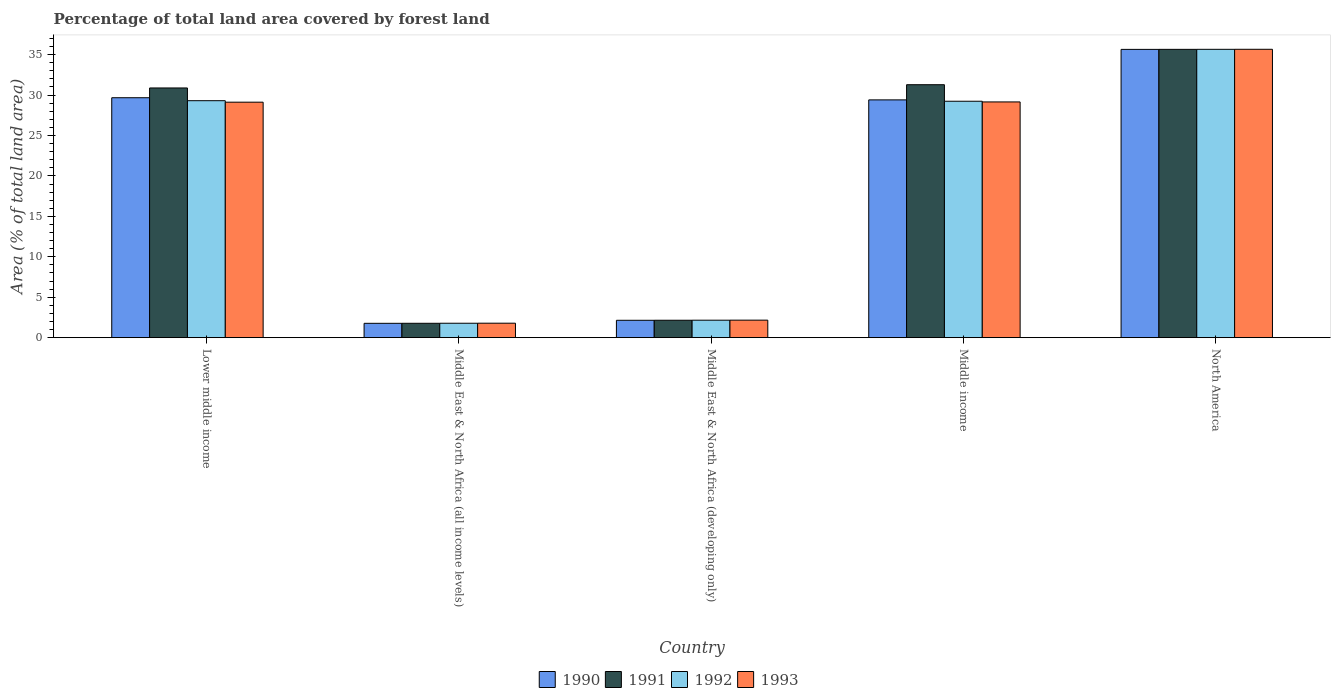How many groups of bars are there?
Your response must be concise. 5. Are the number of bars per tick equal to the number of legend labels?
Provide a succinct answer. Yes. How many bars are there on the 4th tick from the right?
Your response must be concise. 4. What is the label of the 1st group of bars from the left?
Provide a succinct answer. Lower middle income. What is the percentage of forest land in 1991 in North America?
Make the answer very short. 35.65. Across all countries, what is the maximum percentage of forest land in 1993?
Provide a short and direct response. 35.66. Across all countries, what is the minimum percentage of forest land in 1992?
Ensure brevity in your answer.  1.78. In which country was the percentage of forest land in 1992 minimum?
Your response must be concise. Middle East & North Africa (all income levels). What is the total percentage of forest land in 1992 in the graph?
Offer a terse response. 98.14. What is the difference between the percentage of forest land in 1992 in Middle East & North Africa (all income levels) and that in Middle East & North Africa (developing only)?
Your answer should be very brief. -0.38. What is the difference between the percentage of forest land in 1992 in Middle East & North Africa (all income levels) and the percentage of forest land in 1993 in North America?
Provide a short and direct response. -33.88. What is the average percentage of forest land in 1992 per country?
Ensure brevity in your answer.  19.63. What is the difference between the percentage of forest land of/in 1991 and percentage of forest land of/in 1990 in Middle income?
Keep it short and to the point. 1.88. What is the ratio of the percentage of forest land in 1991 in Middle East & North Africa (all income levels) to that in North America?
Provide a succinct answer. 0.05. What is the difference between the highest and the second highest percentage of forest land in 1993?
Offer a very short reply. -6.54. What is the difference between the highest and the lowest percentage of forest land in 1993?
Keep it short and to the point. 33.87. In how many countries, is the percentage of forest land in 1993 greater than the average percentage of forest land in 1993 taken over all countries?
Keep it short and to the point. 3. Is it the case that in every country, the sum of the percentage of forest land in 1991 and percentage of forest land in 1990 is greater than the sum of percentage of forest land in 1992 and percentage of forest land in 1993?
Your response must be concise. No. What does the 3rd bar from the left in Middle East & North Africa (all income levels) represents?
Provide a succinct answer. 1992. What does the 3rd bar from the right in Middle income represents?
Your answer should be compact. 1991. How many bars are there?
Offer a terse response. 20. How many countries are there in the graph?
Give a very brief answer. 5. What is the difference between two consecutive major ticks on the Y-axis?
Offer a terse response. 5. Does the graph contain any zero values?
Offer a very short reply. No. What is the title of the graph?
Your answer should be compact. Percentage of total land area covered by forest land. Does "1992" appear as one of the legend labels in the graph?
Keep it short and to the point. Yes. What is the label or title of the X-axis?
Your answer should be very brief. Country. What is the label or title of the Y-axis?
Keep it short and to the point. Area (% of total land area). What is the Area (% of total land area) of 1990 in Lower middle income?
Your answer should be compact. 29.67. What is the Area (% of total land area) of 1991 in Lower middle income?
Your response must be concise. 30.88. What is the Area (% of total land area) of 1992 in Lower middle income?
Your answer should be compact. 29.31. What is the Area (% of total land area) of 1993 in Lower middle income?
Offer a terse response. 29.12. What is the Area (% of total land area) in 1990 in Middle East & North Africa (all income levels)?
Provide a succinct answer. 1.77. What is the Area (% of total land area) in 1991 in Middle East & North Africa (all income levels)?
Your answer should be very brief. 1.78. What is the Area (% of total land area) in 1992 in Middle East & North Africa (all income levels)?
Provide a succinct answer. 1.78. What is the Area (% of total land area) of 1993 in Middle East & North Africa (all income levels)?
Provide a short and direct response. 1.79. What is the Area (% of total land area) in 1990 in Middle East & North Africa (developing only)?
Ensure brevity in your answer.  2.15. What is the Area (% of total land area) of 1991 in Middle East & North Africa (developing only)?
Offer a very short reply. 2.15. What is the Area (% of total land area) in 1992 in Middle East & North Africa (developing only)?
Your answer should be compact. 2.16. What is the Area (% of total land area) of 1993 in Middle East & North Africa (developing only)?
Provide a succinct answer. 2.17. What is the Area (% of total land area) in 1990 in Middle income?
Ensure brevity in your answer.  29.41. What is the Area (% of total land area) in 1991 in Middle income?
Keep it short and to the point. 31.28. What is the Area (% of total land area) in 1992 in Middle income?
Give a very brief answer. 29.24. What is the Area (% of total land area) in 1993 in Middle income?
Provide a succinct answer. 29.15. What is the Area (% of total land area) of 1990 in North America?
Your answer should be very brief. 35.65. What is the Area (% of total land area) in 1991 in North America?
Your answer should be very brief. 35.65. What is the Area (% of total land area) in 1992 in North America?
Give a very brief answer. 35.66. What is the Area (% of total land area) in 1993 in North America?
Give a very brief answer. 35.66. Across all countries, what is the maximum Area (% of total land area) of 1990?
Your response must be concise. 35.65. Across all countries, what is the maximum Area (% of total land area) in 1991?
Provide a short and direct response. 35.65. Across all countries, what is the maximum Area (% of total land area) in 1992?
Your response must be concise. 35.66. Across all countries, what is the maximum Area (% of total land area) in 1993?
Offer a very short reply. 35.66. Across all countries, what is the minimum Area (% of total land area) in 1990?
Your answer should be very brief. 1.77. Across all countries, what is the minimum Area (% of total land area) of 1991?
Ensure brevity in your answer.  1.78. Across all countries, what is the minimum Area (% of total land area) in 1992?
Provide a short and direct response. 1.78. Across all countries, what is the minimum Area (% of total land area) of 1993?
Your answer should be compact. 1.79. What is the total Area (% of total land area) of 1990 in the graph?
Offer a terse response. 98.65. What is the total Area (% of total land area) in 1991 in the graph?
Your answer should be compact. 101.75. What is the total Area (% of total land area) of 1992 in the graph?
Your answer should be very brief. 98.14. What is the total Area (% of total land area) of 1993 in the graph?
Keep it short and to the point. 97.89. What is the difference between the Area (% of total land area) of 1990 in Lower middle income and that in Middle East & North Africa (all income levels)?
Offer a terse response. 27.9. What is the difference between the Area (% of total land area) of 1991 in Lower middle income and that in Middle East & North Africa (all income levels)?
Provide a succinct answer. 29.1. What is the difference between the Area (% of total land area) of 1992 in Lower middle income and that in Middle East & North Africa (all income levels)?
Provide a short and direct response. 27.52. What is the difference between the Area (% of total land area) of 1993 in Lower middle income and that in Middle East & North Africa (all income levels)?
Make the answer very short. 27.33. What is the difference between the Area (% of total land area) of 1990 in Lower middle income and that in Middle East & North Africa (developing only)?
Provide a short and direct response. 27.52. What is the difference between the Area (% of total land area) of 1991 in Lower middle income and that in Middle East & North Africa (developing only)?
Your answer should be very brief. 28.73. What is the difference between the Area (% of total land area) of 1992 in Lower middle income and that in Middle East & North Africa (developing only)?
Your response must be concise. 27.15. What is the difference between the Area (% of total land area) in 1993 in Lower middle income and that in Middle East & North Africa (developing only)?
Your answer should be compact. 26.96. What is the difference between the Area (% of total land area) in 1990 in Lower middle income and that in Middle income?
Ensure brevity in your answer.  0.27. What is the difference between the Area (% of total land area) in 1991 in Lower middle income and that in Middle income?
Provide a short and direct response. -0.4. What is the difference between the Area (% of total land area) in 1992 in Lower middle income and that in Middle income?
Your response must be concise. 0.07. What is the difference between the Area (% of total land area) in 1993 in Lower middle income and that in Middle income?
Keep it short and to the point. -0.03. What is the difference between the Area (% of total land area) of 1990 in Lower middle income and that in North America?
Give a very brief answer. -5.98. What is the difference between the Area (% of total land area) of 1991 in Lower middle income and that in North America?
Offer a terse response. -4.78. What is the difference between the Area (% of total land area) in 1992 in Lower middle income and that in North America?
Offer a terse response. -6.35. What is the difference between the Area (% of total land area) of 1993 in Lower middle income and that in North America?
Provide a succinct answer. -6.54. What is the difference between the Area (% of total land area) of 1990 in Middle East & North Africa (all income levels) and that in Middle East & North Africa (developing only)?
Offer a very short reply. -0.38. What is the difference between the Area (% of total land area) of 1991 in Middle East & North Africa (all income levels) and that in Middle East & North Africa (developing only)?
Give a very brief answer. -0.38. What is the difference between the Area (% of total land area) of 1992 in Middle East & North Africa (all income levels) and that in Middle East & North Africa (developing only)?
Your answer should be very brief. -0.38. What is the difference between the Area (% of total land area) in 1993 in Middle East & North Africa (all income levels) and that in Middle East & North Africa (developing only)?
Keep it short and to the point. -0.38. What is the difference between the Area (% of total land area) of 1990 in Middle East & North Africa (all income levels) and that in Middle income?
Your answer should be very brief. -27.63. What is the difference between the Area (% of total land area) in 1991 in Middle East & North Africa (all income levels) and that in Middle income?
Ensure brevity in your answer.  -29.5. What is the difference between the Area (% of total land area) in 1992 in Middle East & North Africa (all income levels) and that in Middle income?
Ensure brevity in your answer.  -27.45. What is the difference between the Area (% of total land area) of 1993 in Middle East & North Africa (all income levels) and that in Middle income?
Your answer should be very brief. -27.36. What is the difference between the Area (% of total land area) of 1990 in Middle East & North Africa (all income levels) and that in North America?
Your answer should be very brief. -33.88. What is the difference between the Area (% of total land area) in 1991 in Middle East & North Africa (all income levels) and that in North America?
Provide a short and direct response. -33.88. What is the difference between the Area (% of total land area) of 1992 in Middle East & North Africa (all income levels) and that in North America?
Keep it short and to the point. -33.87. What is the difference between the Area (% of total land area) in 1993 in Middle East & North Africa (all income levels) and that in North America?
Your answer should be compact. -33.87. What is the difference between the Area (% of total land area) in 1990 in Middle East & North Africa (developing only) and that in Middle income?
Ensure brevity in your answer.  -27.26. What is the difference between the Area (% of total land area) of 1991 in Middle East & North Africa (developing only) and that in Middle income?
Offer a terse response. -29.13. What is the difference between the Area (% of total land area) in 1992 in Middle East & North Africa (developing only) and that in Middle income?
Your answer should be very brief. -27.08. What is the difference between the Area (% of total land area) in 1993 in Middle East & North Africa (developing only) and that in Middle income?
Offer a very short reply. -26.99. What is the difference between the Area (% of total land area) of 1990 in Middle East & North Africa (developing only) and that in North America?
Provide a succinct answer. -33.5. What is the difference between the Area (% of total land area) of 1991 in Middle East & North Africa (developing only) and that in North America?
Your response must be concise. -33.5. What is the difference between the Area (% of total land area) of 1992 in Middle East & North Africa (developing only) and that in North America?
Provide a succinct answer. -33.5. What is the difference between the Area (% of total land area) of 1993 in Middle East & North Africa (developing only) and that in North America?
Keep it short and to the point. -33.5. What is the difference between the Area (% of total land area) in 1990 in Middle income and that in North America?
Your answer should be compact. -6.25. What is the difference between the Area (% of total land area) in 1991 in Middle income and that in North America?
Provide a succinct answer. -4.37. What is the difference between the Area (% of total land area) of 1992 in Middle income and that in North America?
Provide a short and direct response. -6.42. What is the difference between the Area (% of total land area) of 1993 in Middle income and that in North America?
Your response must be concise. -6.51. What is the difference between the Area (% of total land area) of 1990 in Lower middle income and the Area (% of total land area) of 1991 in Middle East & North Africa (all income levels)?
Provide a short and direct response. 27.89. What is the difference between the Area (% of total land area) in 1990 in Lower middle income and the Area (% of total land area) in 1992 in Middle East & North Africa (all income levels)?
Your response must be concise. 27.89. What is the difference between the Area (% of total land area) in 1990 in Lower middle income and the Area (% of total land area) in 1993 in Middle East & North Africa (all income levels)?
Keep it short and to the point. 27.88. What is the difference between the Area (% of total land area) in 1991 in Lower middle income and the Area (% of total land area) in 1992 in Middle East & North Africa (all income levels)?
Provide a succinct answer. 29.1. What is the difference between the Area (% of total land area) in 1991 in Lower middle income and the Area (% of total land area) in 1993 in Middle East & North Africa (all income levels)?
Ensure brevity in your answer.  29.09. What is the difference between the Area (% of total land area) of 1992 in Lower middle income and the Area (% of total land area) of 1993 in Middle East & North Africa (all income levels)?
Provide a succinct answer. 27.52. What is the difference between the Area (% of total land area) in 1990 in Lower middle income and the Area (% of total land area) in 1991 in Middle East & North Africa (developing only)?
Keep it short and to the point. 27.52. What is the difference between the Area (% of total land area) in 1990 in Lower middle income and the Area (% of total land area) in 1992 in Middle East & North Africa (developing only)?
Give a very brief answer. 27.51. What is the difference between the Area (% of total land area) in 1990 in Lower middle income and the Area (% of total land area) in 1993 in Middle East & North Africa (developing only)?
Ensure brevity in your answer.  27.51. What is the difference between the Area (% of total land area) in 1991 in Lower middle income and the Area (% of total land area) in 1992 in Middle East & North Africa (developing only)?
Provide a short and direct response. 28.72. What is the difference between the Area (% of total land area) of 1991 in Lower middle income and the Area (% of total land area) of 1993 in Middle East & North Africa (developing only)?
Provide a succinct answer. 28.71. What is the difference between the Area (% of total land area) of 1992 in Lower middle income and the Area (% of total land area) of 1993 in Middle East & North Africa (developing only)?
Offer a terse response. 27.14. What is the difference between the Area (% of total land area) of 1990 in Lower middle income and the Area (% of total land area) of 1991 in Middle income?
Your answer should be very brief. -1.61. What is the difference between the Area (% of total land area) of 1990 in Lower middle income and the Area (% of total land area) of 1992 in Middle income?
Offer a terse response. 0.43. What is the difference between the Area (% of total land area) in 1990 in Lower middle income and the Area (% of total land area) in 1993 in Middle income?
Offer a terse response. 0.52. What is the difference between the Area (% of total land area) of 1991 in Lower middle income and the Area (% of total land area) of 1992 in Middle income?
Your answer should be compact. 1.64. What is the difference between the Area (% of total land area) in 1991 in Lower middle income and the Area (% of total land area) in 1993 in Middle income?
Your answer should be very brief. 1.73. What is the difference between the Area (% of total land area) in 1992 in Lower middle income and the Area (% of total land area) in 1993 in Middle income?
Give a very brief answer. 0.15. What is the difference between the Area (% of total land area) in 1990 in Lower middle income and the Area (% of total land area) in 1991 in North America?
Provide a short and direct response. -5.98. What is the difference between the Area (% of total land area) of 1990 in Lower middle income and the Area (% of total land area) of 1992 in North America?
Make the answer very short. -5.99. What is the difference between the Area (% of total land area) in 1990 in Lower middle income and the Area (% of total land area) in 1993 in North America?
Your answer should be very brief. -5.99. What is the difference between the Area (% of total land area) of 1991 in Lower middle income and the Area (% of total land area) of 1992 in North America?
Offer a very short reply. -4.78. What is the difference between the Area (% of total land area) in 1991 in Lower middle income and the Area (% of total land area) in 1993 in North America?
Keep it short and to the point. -4.78. What is the difference between the Area (% of total land area) in 1992 in Lower middle income and the Area (% of total land area) in 1993 in North America?
Offer a very short reply. -6.36. What is the difference between the Area (% of total land area) of 1990 in Middle East & North Africa (all income levels) and the Area (% of total land area) of 1991 in Middle East & North Africa (developing only)?
Keep it short and to the point. -0.38. What is the difference between the Area (% of total land area) of 1990 in Middle East & North Africa (all income levels) and the Area (% of total land area) of 1992 in Middle East & North Africa (developing only)?
Ensure brevity in your answer.  -0.39. What is the difference between the Area (% of total land area) in 1990 in Middle East & North Africa (all income levels) and the Area (% of total land area) in 1993 in Middle East & North Africa (developing only)?
Your response must be concise. -0.39. What is the difference between the Area (% of total land area) of 1991 in Middle East & North Africa (all income levels) and the Area (% of total land area) of 1992 in Middle East & North Africa (developing only)?
Your response must be concise. -0.38. What is the difference between the Area (% of total land area) in 1991 in Middle East & North Africa (all income levels) and the Area (% of total land area) in 1993 in Middle East & North Africa (developing only)?
Offer a very short reply. -0.39. What is the difference between the Area (% of total land area) in 1992 in Middle East & North Africa (all income levels) and the Area (% of total land area) in 1993 in Middle East & North Africa (developing only)?
Offer a terse response. -0.38. What is the difference between the Area (% of total land area) of 1990 in Middle East & North Africa (all income levels) and the Area (% of total land area) of 1991 in Middle income?
Offer a terse response. -29.51. What is the difference between the Area (% of total land area) in 1990 in Middle East & North Africa (all income levels) and the Area (% of total land area) in 1992 in Middle income?
Offer a terse response. -27.46. What is the difference between the Area (% of total land area) of 1990 in Middle East & North Africa (all income levels) and the Area (% of total land area) of 1993 in Middle income?
Make the answer very short. -27.38. What is the difference between the Area (% of total land area) of 1991 in Middle East & North Africa (all income levels) and the Area (% of total land area) of 1992 in Middle income?
Make the answer very short. -27.46. What is the difference between the Area (% of total land area) in 1991 in Middle East & North Africa (all income levels) and the Area (% of total land area) in 1993 in Middle income?
Make the answer very short. -27.37. What is the difference between the Area (% of total land area) in 1992 in Middle East & North Africa (all income levels) and the Area (% of total land area) in 1993 in Middle income?
Provide a short and direct response. -27.37. What is the difference between the Area (% of total land area) in 1990 in Middle East & North Africa (all income levels) and the Area (% of total land area) in 1991 in North America?
Your answer should be very brief. -33.88. What is the difference between the Area (% of total land area) in 1990 in Middle East & North Africa (all income levels) and the Area (% of total land area) in 1992 in North America?
Keep it short and to the point. -33.88. What is the difference between the Area (% of total land area) of 1990 in Middle East & North Africa (all income levels) and the Area (% of total land area) of 1993 in North America?
Give a very brief answer. -33.89. What is the difference between the Area (% of total land area) of 1991 in Middle East & North Africa (all income levels) and the Area (% of total land area) of 1992 in North America?
Offer a very short reply. -33.88. What is the difference between the Area (% of total land area) in 1991 in Middle East & North Africa (all income levels) and the Area (% of total land area) in 1993 in North America?
Give a very brief answer. -33.88. What is the difference between the Area (% of total land area) in 1992 in Middle East & North Africa (all income levels) and the Area (% of total land area) in 1993 in North America?
Your response must be concise. -33.88. What is the difference between the Area (% of total land area) in 1990 in Middle East & North Africa (developing only) and the Area (% of total land area) in 1991 in Middle income?
Make the answer very short. -29.13. What is the difference between the Area (% of total land area) in 1990 in Middle East & North Africa (developing only) and the Area (% of total land area) in 1992 in Middle income?
Keep it short and to the point. -27.09. What is the difference between the Area (% of total land area) in 1990 in Middle East & North Africa (developing only) and the Area (% of total land area) in 1993 in Middle income?
Your response must be concise. -27. What is the difference between the Area (% of total land area) of 1991 in Middle East & North Africa (developing only) and the Area (% of total land area) of 1992 in Middle income?
Offer a terse response. -27.08. What is the difference between the Area (% of total land area) in 1991 in Middle East & North Africa (developing only) and the Area (% of total land area) in 1993 in Middle income?
Keep it short and to the point. -27. What is the difference between the Area (% of total land area) in 1992 in Middle East & North Africa (developing only) and the Area (% of total land area) in 1993 in Middle income?
Offer a very short reply. -26.99. What is the difference between the Area (% of total land area) in 1990 in Middle East & North Africa (developing only) and the Area (% of total land area) in 1991 in North America?
Offer a terse response. -33.51. What is the difference between the Area (% of total land area) in 1990 in Middle East & North Africa (developing only) and the Area (% of total land area) in 1992 in North America?
Your answer should be compact. -33.51. What is the difference between the Area (% of total land area) in 1990 in Middle East & North Africa (developing only) and the Area (% of total land area) in 1993 in North America?
Provide a short and direct response. -33.51. What is the difference between the Area (% of total land area) of 1991 in Middle East & North Africa (developing only) and the Area (% of total land area) of 1992 in North America?
Provide a succinct answer. -33.5. What is the difference between the Area (% of total land area) in 1991 in Middle East & North Africa (developing only) and the Area (% of total land area) in 1993 in North America?
Keep it short and to the point. -33.51. What is the difference between the Area (% of total land area) of 1992 in Middle East & North Africa (developing only) and the Area (% of total land area) of 1993 in North America?
Your answer should be compact. -33.5. What is the difference between the Area (% of total land area) in 1990 in Middle income and the Area (% of total land area) in 1991 in North America?
Keep it short and to the point. -6.25. What is the difference between the Area (% of total land area) of 1990 in Middle income and the Area (% of total land area) of 1992 in North America?
Offer a very short reply. -6.25. What is the difference between the Area (% of total land area) of 1990 in Middle income and the Area (% of total land area) of 1993 in North America?
Make the answer very short. -6.26. What is the difference between the Area (% of total land area) in 1991 in Middle income and the Area (% of total land area) in 1992 in North America?
Your answer should be compact. -4.38. What is the difference between the Area (% of total land area) in 1991 in Middle income and the Area (% of total land area) in 1993 in North America?
Make the answer very short. -4.38. What is the difference between the Area (% of total land area) in 1992 in Middle income and the Area (% of total land area) in 1993 in North America?
Your answer should be very brief. -6.42. What is the average Area (% of total land area) in 1990 per country?
Provide a short and direct response. 19.73. What is the average Area (% of total land area) of 1991 per country?
Make the answer very short. 20.35. What is the average Area (% of total land area) of 1992 per country?
Keep it short and to the point. 19.63. What is the average Area (% of total land area) of 1993 per country?
Keep it short and to the point. 19.58. What is the difference between the Area (% of total land area) of 1990 and Area (% of total land area) of 1991 in Lower middle income?
Your answer should be compact. -1.21. What is the difference between the Area (% of total land area) in 1990 and Area (% of total land area) in 1992 in Lower middle income?
Make the answer very short. 0.37. What is the difference between the Area (% of total land area) of 1990 and Area (% of total land area) of 1993 in Lower middle income?
Make the answer very short. 0.55. What is the difference between the Area (% of total land area) in 1991 and Area (% of total land area) in 1992 in Lower middle income?
Your answer should be very brief. 1.57. What is the difference between the Area (% of total land area) in 1991 and Area (% of total land area) in 1993 in Lower middle income?
Make the answer very short. 1.76. What is the difference between the Area (% of total land area) of 1992 and Area (% of total land area) of 1993 in Lower middle income?
Offer a terse response. 0.18. What is the difference between the Area (% of total land area) in 1990 and Area (% of total land area) in 1991 in Middle East & North Africa (all income levels)?
Give a very brief answer. -0.01. What is the difference between the Area (% of total land area) of 1990 and Area (% of total land area) of 1992 in Middle East & North Africa (all income levels)?
Provide a succinct answer. -0.01. What is the difference between the Area (% of total land area) of 1990 and Area (% of total land area) of 1993 in Middle East & North Africa (all income levels)?
Offer a very short reply. -0.02. What is the difference between the Area (% of total land area) of 1991 and Area (% of total land area) of 1992 in Middle East & North Africa (all income levels)?
Offer a terse response. -0.01. What is the difference between the Area (% of total land area) of 1991 and Area (% of total land area) of 1993 in Middle East & North Africa (all income levels)?
Your response must be concise. -0.01. What is the difference between the Area (% of total land area) of 1992 and Area (% of total land area) of 1993 in Middle East & North Africa (all income levels)?
Make the answer very short. -0.01. What is the difference between the Area (% of total land area) of 1990 and Area (% of total land area) of 1991 in Middle East & North Africa (developing only)?
Provide a succinct answer. -0.01. What is the difference between the Area (% of total land area) of 1990 and Area (% of total land area) of 1992 in Middle East & North Africa (developing only)?
Provide a short and direct response. -0.01. What is the difference between the Area (% of total land area) in 1990 and Area (% of total land area) in 1993 in Middle East & North Africa (developing only)?
Your answer should be compact. -0.02. What is the difference between the Area (% of total land area) in 1991 and Area (% of total land area) in 1992 in Middle East & North Africa (developing only)?
Offer a terse response. -0.01. What is the difference between the Area (% of total land area) of 1991 and Area (% of total land area) of 1993 in Middle East & North Africa (developing only)?
Your answer should be compact. -0.01. What is the difference between the Area (% of total land area) of 1992 and Area (% of total land area) of 1993 in Middle East & North Africa (developing only)?
Your response must be concise. -0.01. What is the difference between the Area (% of total land area) in 1990 and Area (% of total land area) in 1991 in Middle income?
Ensure brevity in your answer.  -1.88. What is the difference between the Area (% of total land area) in 1990 and Area (% of total land area) in 1992 in Middle income?
Provide a short and direct response. 0.17. What is the difference between the Area (% of total land area) of 1990 and Area (% of total land area) of 1993 in Middle income?
Make the answer very short. 0.25. What is the difference between the Area (% of total land area) of 1991 and Area (% of total land area) of 1992 in Middle income?
Keep it short and to the point. 2.05. What is the difference between the Area (% of total land area) of 1991 and Area (% of total land area) of 1993 in Middle income?
Make the answer very short. 2.13. What is the difference between the Area (% of total land area) in 1992 and Area (% of total land area) in 1993 in Middle income?
Your response must be concise. 0.08. What is the difference between the Area (% of total land area) in 1990 and Area (% of total land area) in 1991 in North America?
Your answer should be very brief. -0. What is the difference between the Area (% of total land area) of 1990 and Area (% of total land area) of 1992 in North America?
Ensure brevity in your answer.  -0.01. What is the difference between the Area (% of total land area) of 1990 and Area (% of total land area) of 1993 in North America?
Your response must be concise. -0.01. What is the difference between the Area (% of total land area) in 1991 and Area (% of total land area) in 1992 in North America?
Offer a very short reply. -0. What is the difference between the Area (% of total land area) of 1991 and Area (% of total land area) of 1993 in North America?
Give a very brief answer. -0.01. What is the difference between the Area (% of total land area) of 1992 and Area (% of total land area) of 1993 in North America?
Your answer should be very brief. -0. What is the ratio of the Area (% of total land area) of 1990 in Lower middle income to that in Middle East & North Africa (all income levels)?
Keep it short and to the point. 16.73. What is the ratio of the Area (% of total land area) of 1991 in Lower middle income to that in Middle East & North Africa (all income levels)?
Your answer should be compact. 17.36. What is the ratio of the Area (% of total land area) in 1992 in Lower middle income to that in Middle East & North Africa (all income levels)?
Your response must be concise. 16.43. What is the ratio of the Area (% of total land area) in 1993 in Lower middle income to that in Middle East & North Africa (all income levels)?
Give a very brief answer. 16.28. What is the ratio of the Area (% of total land area) in 1990 in Lower middle income to that in Middle East & North Africa (developing only)?
Ensure brevity in your answer.  13.81. What is the ratio of the Area (% of total land area) in 1991 in Lower middle income to that in Middle East & North Africa (developing only)?
Your response must be concise. 14.34. What is the ratio of the Area (% of total land area) of 1992 in Lower middle income to that in Middle East & North Africa (developing only)?
Your answer should be compact. 13.57. What is the ratio of the Area (% of total land area) in 1993 in Lower middle income to that in Middle East & North Africa (developing only)?
Ensure brevity in your answer.  13.45. What is the ratio of the Area (% of total land area) in 1990 in Lower middle income to that in Middle income?
Your response must be concise. 1.01. What is the ratio of the Area (% of total land area) of 1991 in Lower middle income to that in Middle income?
Your answer should be very brief. 0.99. What is the ratio of the Area (% of total land area) of 1992 in Lower middle income to that in Middle income?
Offer a very short reply. 1. What is the ratio of the Area (% of total land area) in 1990 in Lower middle income to that in North America?
Provide a short and direct response. 0.83. What is the ratio of the Area (% of total land area) in 1991 in Lower middle income to that in North America?
Give a very brief answer. 0.87. What is the ratio of the Area (% of total land area) in 1992 in Lower middle income to that in North America?
Keep it short and to the point. 0.82. What is the ratio of the Area (% of total land area) in 1993 in Lower middle income to that in North America?
Your answer should be very brief. 0.82. What is the ratio of the Area (% of total land area) in 1990 in Middle East & North Africa (all income levels) to that in Middle East & North Africa (developing only)?
Ensure brevity in your answer.  0.83. What is the ratio of the Area (% of total land area) of 1991 in Middle East & North Africa (all income levels) to that in Middle East & North Africa (developing only)?
Provide a short and direct response. 0.83. What is the ratio of the Area (% of total land area) of 1992 in Middle East & North Africa (all income levels) to that in Middle East & North Africa (developing only)?
Your answer should be compact. 0.83. What is the ratio of the Area (% of total land area) of 1993 in Middle East & North Africa (all income levels) to that in Middle East & North Africa (developing only)?
Keep it short and to the point. 0.83. What is the ratio of the Area (% of total land area) in 1990 in Middle East & North Africa (all income levels) to that in Middle income?
Your answer should be very brief. 0.06. What is the ratio of the Area (% of total land area) in 1991 in Middle East & North Africa (all income levels) to that in Middle income?
Provide a short and direct response. 0.06. What is the ratio of the Area (% of total land area) in 1992 in Middle East & North Africa (all income levels) to that in Middle income?
Your answer should be compact. 0.06. What is the ratio of the Area (% of total land area) in 1993 in Middle East & North Africa (all income levels) to that in Middle income?
Your answer should be very brief. 0.06. What is the ratio of the Area (% of total land area) in 1990 in Middle East & North Africa (all income levels) to that in North America?
Provide a short and direct response. 0.05. What is the ratio of the Area (% of total land area) in 1991 in Middle East & North Africa (all income levels) to that in North America?
Make the answer very short. 0.05. What is the ratio of the Area (% of total land area) in 1993 in Middle East & North Africa (all income levels) to that in North America?
Ensure brevity in your answer.  0.05. What is the ratio of the Area (% of total land area) of 1990 in Middle East & North Africa (developing only) to that in Middle income?
Provide a succinct answer. 0.07. What is the ratio of the Area (% of total land area) of 1991 in Middle East & North Africa (developing only) to that in Middle income?
Offer a very short reply. 0.07. What is the ratio of the Area (% of total land area) in 1992 in Middle East & North Africa (developing only) to that in Middle income?
Offer a very short reply. 0.07. What is the ratio of the Area (% of total land area) of 1993 in Middle East & North Africa (developing only) to that in Middle income?
Offer a terse response. 0.07. What is the ratio of the Area (% of total land area) of 1990 in Middle East & North Africa (developing only) to that in North America?
Offer a very short reply. 0.06. What is the ratio of the Area (% of total land area) in 1991 in Middle East & North Africa (developing only) to that in North America?
Give a very brief answer. 0.06. What is the ratio of the Area (% of total land area) of 1992 in Middle East & North Africa (developing only) to that in North America?
Provide a succinct answer. 0.06. What is the ratio of the Area (% of total land area) of 1993 in Middle East & North Africa (developing only) to that in North America?
Your answer should be very brief. 0.06. What is the ratio of the Area (% of total land area) in 1990 in Middle income to that in North America?
Keep it short and to the point. 0.82. What is the ratio of the Area (% of total land area) in 1991 in Middle income to that in North America?
Your response must be concise. 0.88. What is the ratio of the Area (% of total land area) of 1992 in Middle income to that in North America?
Give a very brief answer. 0.82. What is the ratio of the Area (% of total land area) in 1993 in Middle income to that in North America?
Offer a very short reply. 0.82. What is the difference between the highest and the second highest Area (% of total land area) of 1990?
Offer a very short reply. 5.98. What is the difference between the highest and the second highest Area (% of total land area) in 1991?
Offer a terse response. 4.37. What is the difference between the highest and the second highest Area (% of total land area) in 1992?
Ensure brevity in your answer.  6.35. What is the difference between the highest and the second highest Area (% of total land area) of 1993?
Your response must be concise. 6.51. What is the difference between the highest and the lowest Area (% of total land area) of 1990?
Your response must be concise. 33.88. What is the difference between the highest and the lowest Area (% of total land area) of 1991?
Give a very brief answer. 33.88. What is the difference between the highest and the lowest Area (% of total land area) in 1992?
Keep it short and to the point. 33.87. What is the difference between the highest and the lowest Area (% of total land area) of 1993?
Your answer should be very brief. 33.87. 